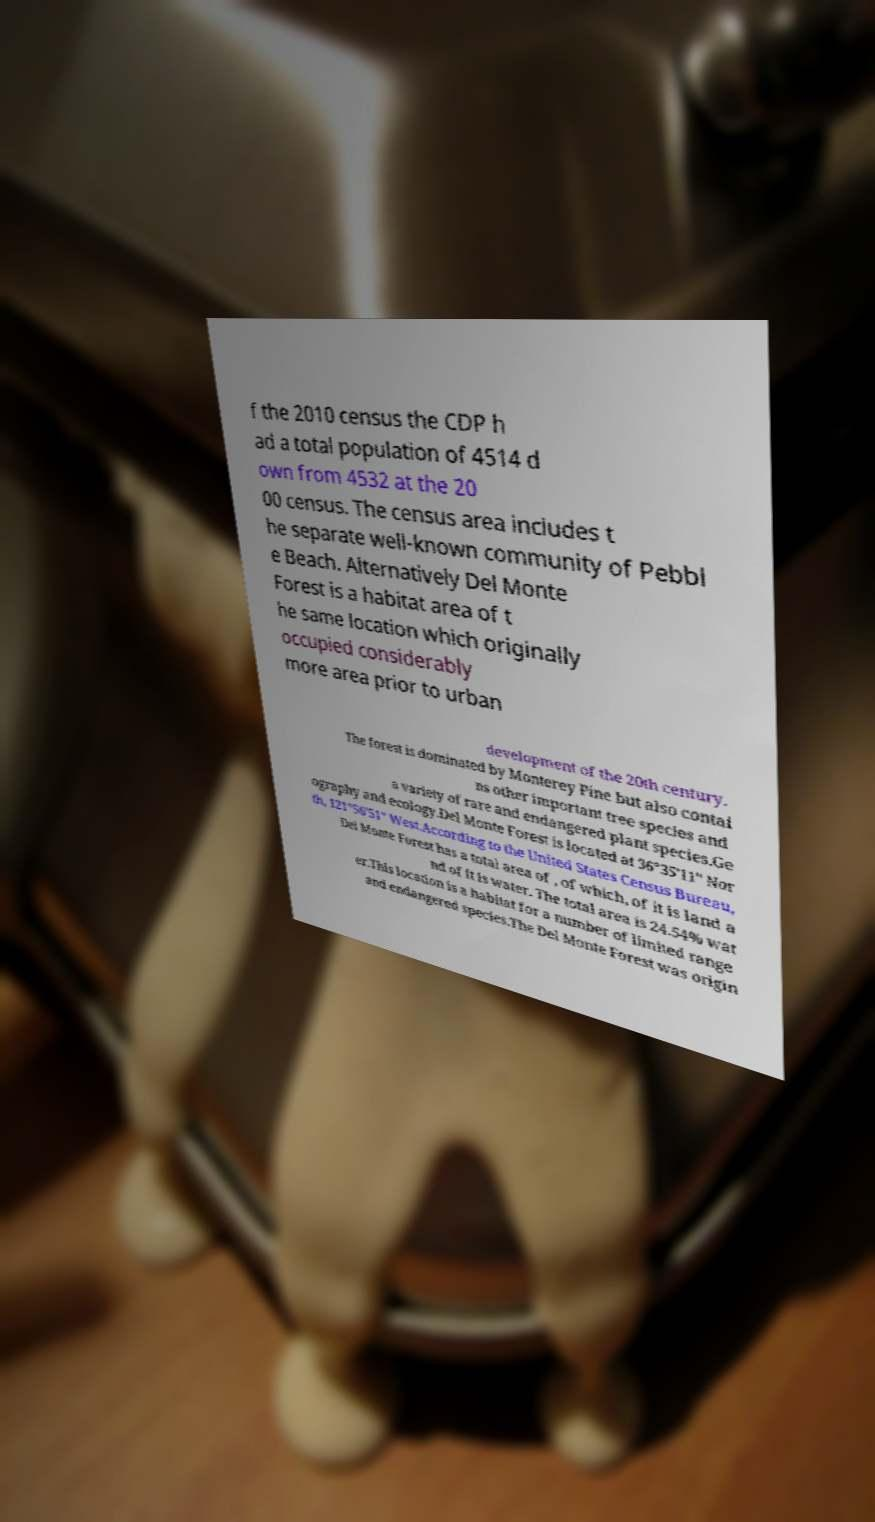For documentation purposes, I need the text within this image transcribed. Could you provide that? f the 2010 census the CDP h ad a total population of 4514 d own from 4532 at the 20 00 census. The census area includes t he separate well-known community of Pebbl e Beach. Alternatively Del Monte Forest is a habitat area of t he same location which originally occupied considerably more area prior to urban development of the 20th century. The forest is dominated by Monterey Pine but also contai ns other important tree species and a variety of rare and endangered plant species.Ge ography and ecology.Del Monte Forest is located at 36°35'11" Nor th, 121°56'51" West.According to the United States Census Bureau, Del Monte Forest has a total area of , of which, of it is land a nd of it is water. The total area is 24.54% wat er.This location is a habitat for a number of limited range and endangered species.The Del Monte Forest was origin 